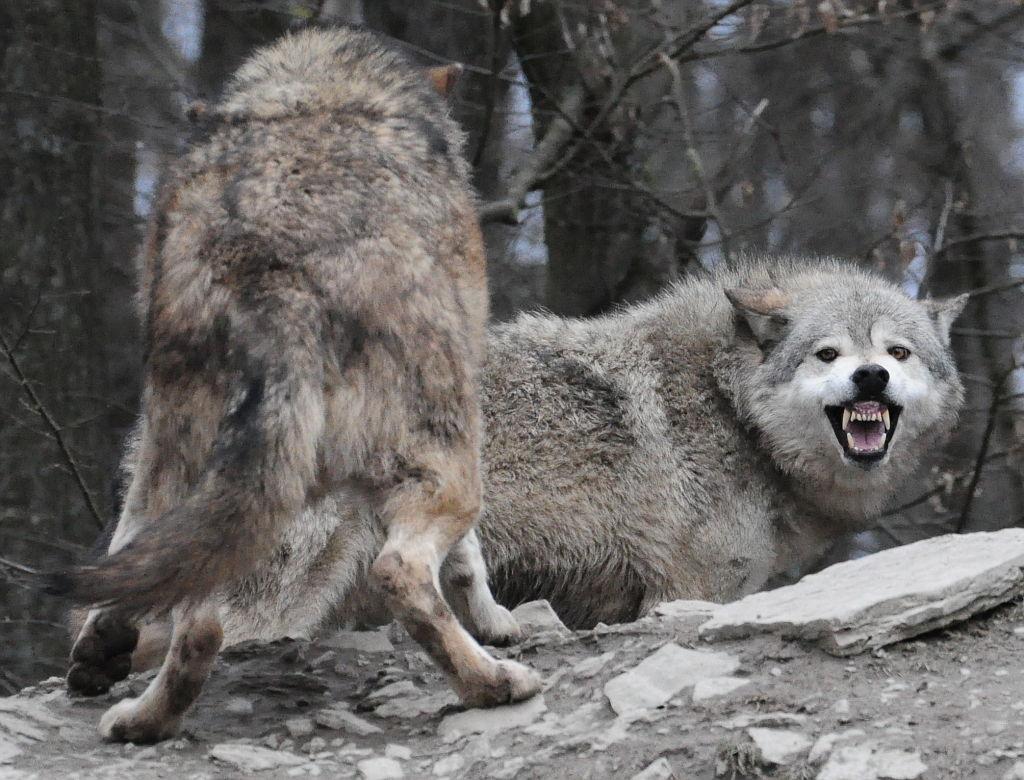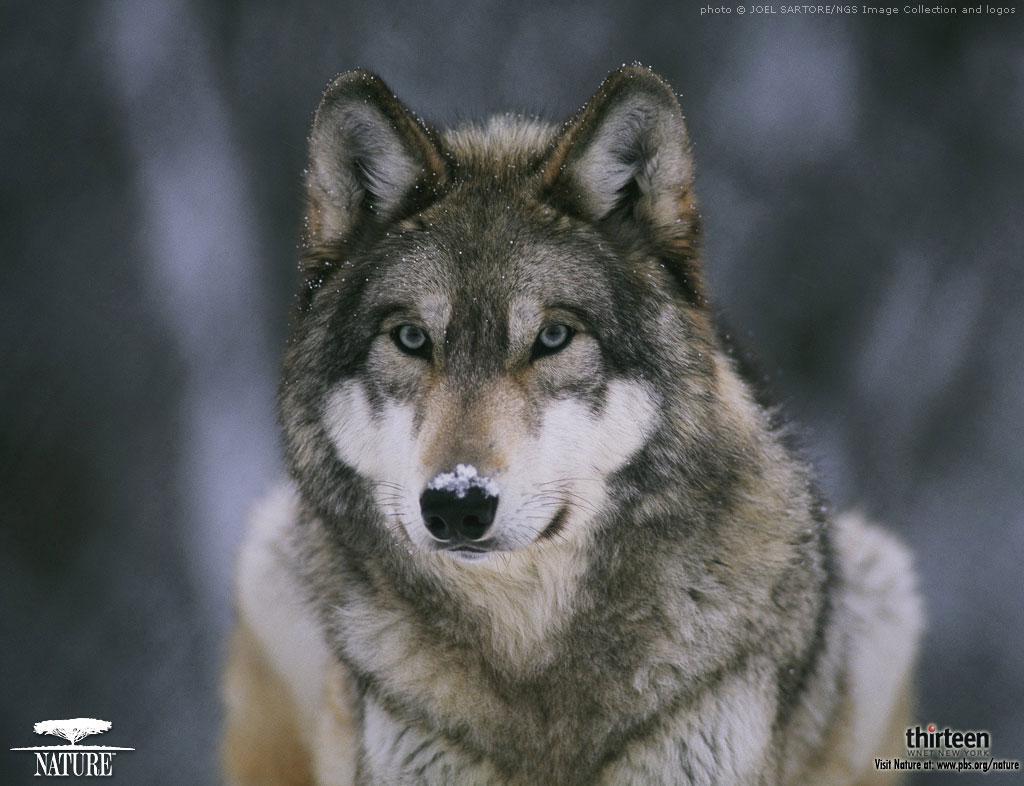The first image is the image on the left, the second image is the image on the right. Assess this claim about the two images: "The wolf in the image on the right has its mouth closed.". Correct or not? Answer yes or no. Yes. The first image is the image on the left, the second image is the image on the right. Examine the images to the left and right. Is the description "One image features one wolf with snow on its nose, and the other image contains a single wolf, which has its mouth open showing its teeth and stands with its body forward and its head turned rightward." accurate? Answer yes or no. No. 